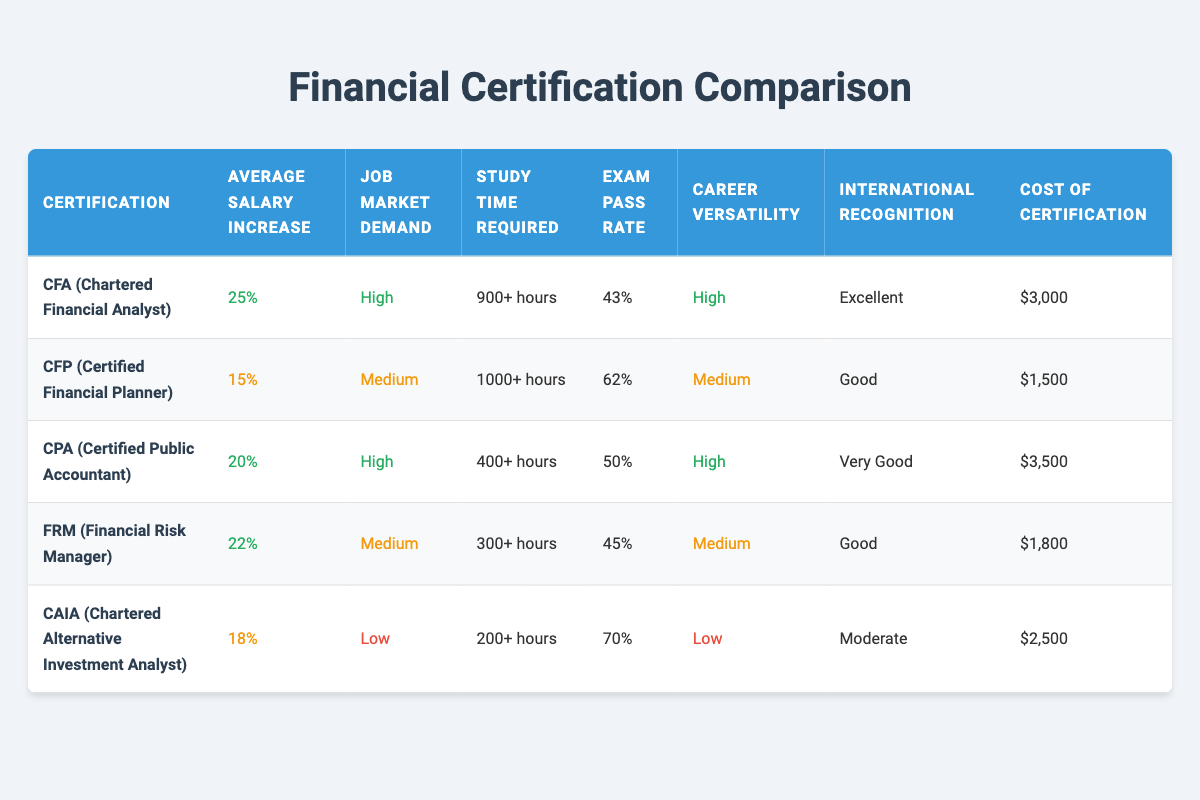What is the average salary increase for a CFA certification? According to the table, the average salary increase for a CFA certification is listed as 25%.
Answer: 25% Which certification has the highest job market demand? The table indicates that both CFA and CPA certifications have a job market demand classified as "High," making them the certifications with the highest demand.
Answer: CFA and CPA What is the exam pass rate for the CFP certification? The table shows that the exam pass rate for the CFP certification is 62%.
Answer: 62% Are the costs of the CFA and CPA certifications the same? The table lists the cost of the CFA certification at $3,000 and the CPA certification at $3,500. These values are not the same, indicating that CPA is more expensive.
Answer: No What is the average study time required for the CAIA certification? According to the table, the study time required for the CAIA certification is 200+ hours.
Answer: 200+ hours What is the difference in average salary increase between CPA and CFP certifications? The average salary increase for CPA is 20%, and for CFP it is 15%. The difference is calculated as 20% - 15% = 5%.
Answer: 5% Which certification has the lowest career versatility? The table indicates that CAIA has a career versatility rated as "Low," making it the certification with the lowest versatility.
Answer: CAIA Is the exam pass rate for FRM higher than that for CFA? In the table, the exam pass rate for FRM is 45%, while for CFA, it is 43%. Since 45% is greater than 43%, the exam pass rate for FRM is indeed higher.
Answer: Yes Among the certifications listed, which one is recognized internationally as "Excellent"? The table shows that only the CFA certification is recognized internationally as "Excellent."
Answer: CFA 